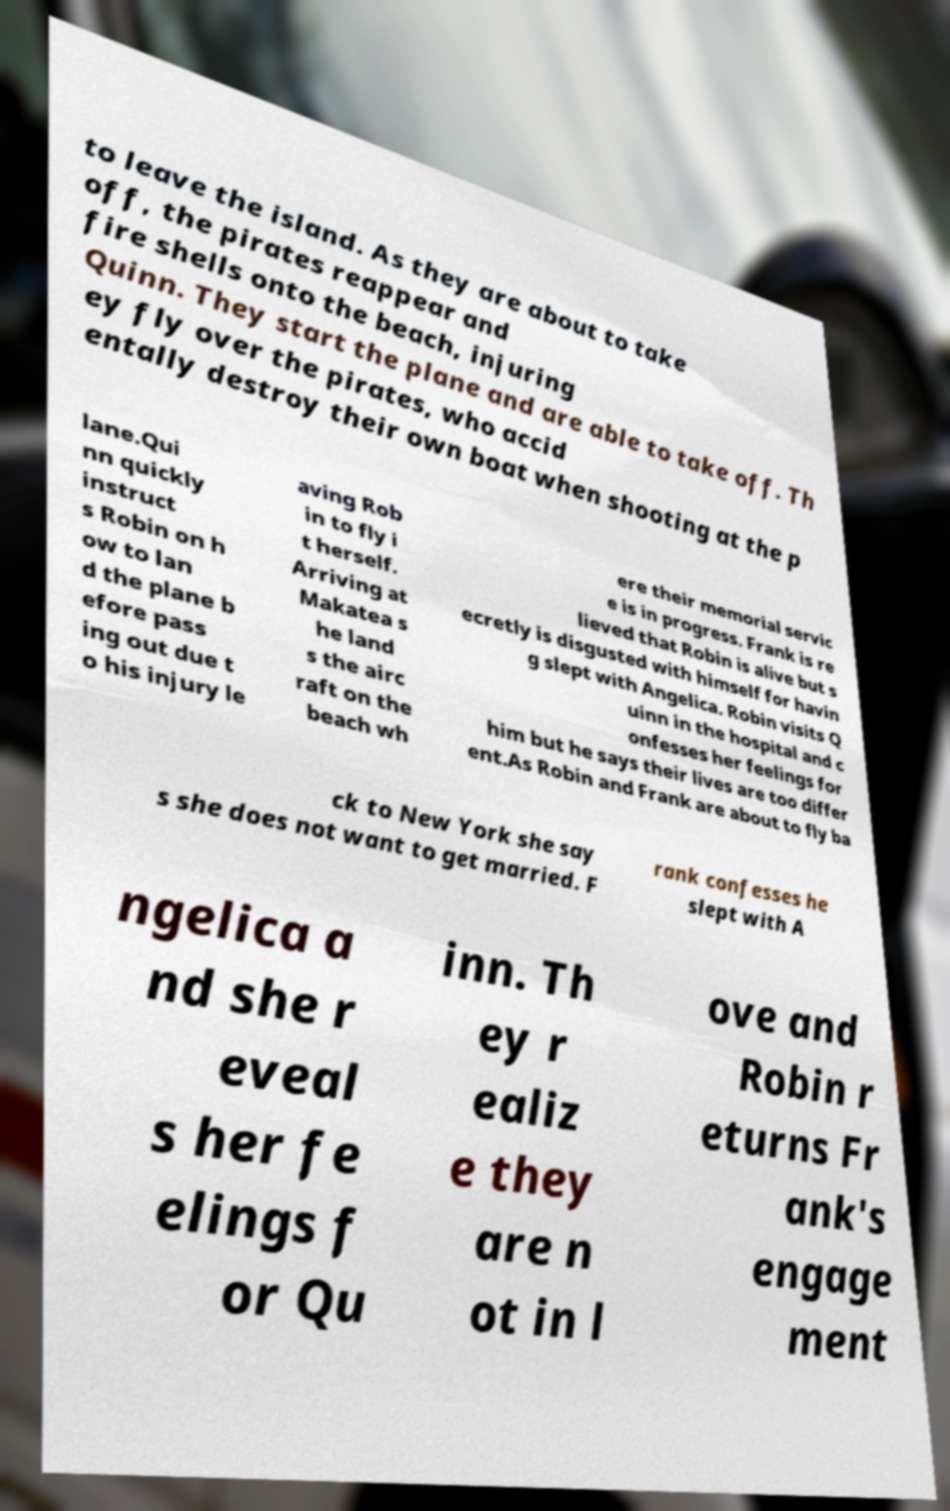Can you read and provide the text displayed in the image?This photo seems to have some interesting text. Can you extract and type it out for me? to leave the island. As they are about to take off, the pirates reappear and fire shells onto the beach, injuring Quinn. They start the plane and are able to take off. Th ey fly over the pirates, who accid entally destroy their own boat when shooting at the p lane.Qui nn quickly instruct s Robin on h ow to lan d the plane b efore pass ing out due t o his injury le aving Rob in to fly i t herself. Arriving at Makatea s he land s the airc raft on the beach wh ere their memorial servic e is in progress. Frank is re lieved that Robin is alive but s ecretly is disgusted with himself for havin g slept with Angelica. Robin visits Q uinn in the hospital and c onfesses her feelings for him but he says their lives are too differ ent.As Robin and Frank are about to fly ba ck to New York she say s she does not want to get married. F rank confesses he slept with A ngelica a nd she r eveal s her fe elings f or Qu inn. Th ey r ealiz e they are n ot in l ove and Robin r eturns Fr ank's engage ment 